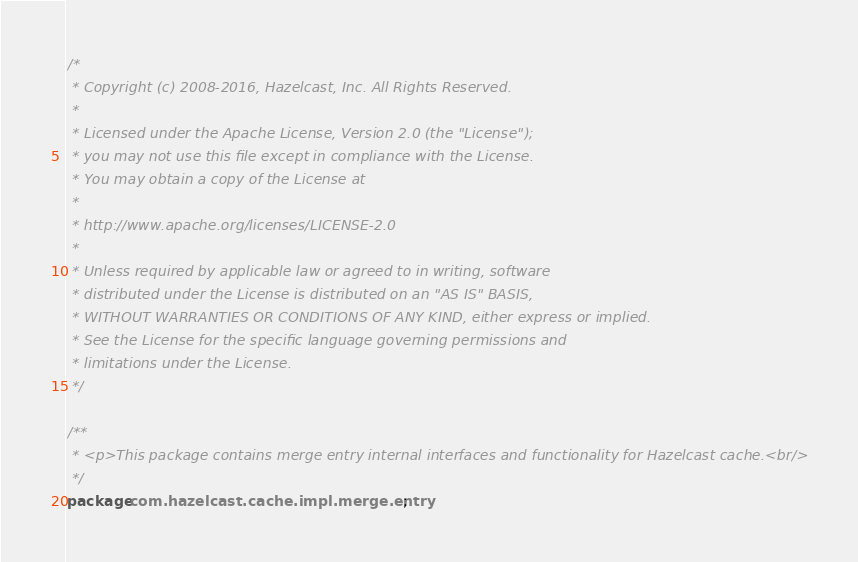<code> <loc_0><loc_0><loc_500><loc_500><_Java_>/*
 * Copyright (c) 2008-2016, Hazelcast, Inc. All Rights Reserved.
 *
 * Licensed under the Apache License, Version 2.0 (the "License");
 * you may not use this file except in compliance with the License.
 * You may obtain a copy of the License at
 *
 * http://www.apache.org/licenses/LICENSE-2.0
 *
 * Unless required by applicable law or agreed to in writing, software
 * distributed under the License is distributed on an "AS IS" BASIS,
 * WITHOUT WARRANTIES OR CONDITIONS OF ANY KIND, either express or implied.
 * See the License for the specific language governing permissions and
 * limitations under the License.
 */

/**
 * <p>This package contains merge entry internal interfaces and functionality for Hazelcast cache.<br/>
 */
package com.hazelcast.cache.impl.merge.entry;
</code> 